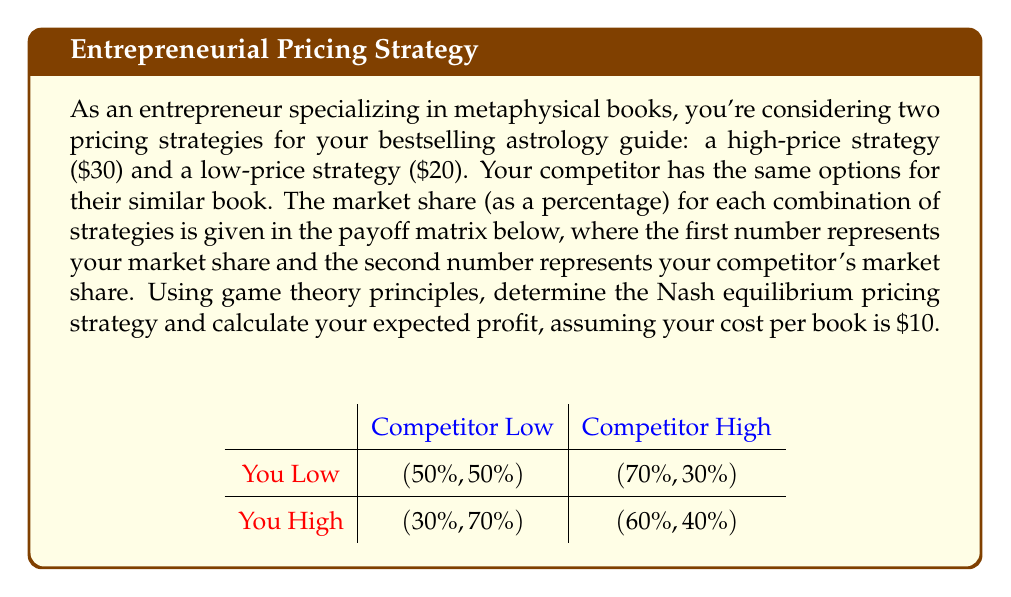Can you solve this math problem? To solve this problem, we'll follow these steps:

1. Identify the Nash equilibrium:
   A Nash equilibrium occurs when neither player can unilaterally change their strategy to increase their payoff.

   Let's analyze each scenario:
   a) If competitor chooses Low:
      - If you choose Low, your payoff is 50%
      - If you choose High, your payoff is 30%
      You prefer Low when competitor is Low.

   b) If competitor chooses High:
      - If you choose Low, your payoff is 70%
      - If you choose High, your payoff is 60%
      You prefer Low when competitor is High.

   c) If you choose Low:
      - If competitor chooses Low, their payoff is 50%
      - If competitor chooses High, their payoff is 30%
      Competitor prefers Low when you are Low.

   d) If you choose High:
      - If competitor chooses Low, their payoff is 70%
      - If competitor chooses High, their payoff is 40%
      Competitor prefers Low when you are High.

   The Nash equilibrium is (Low, Low), as neither player has an incentive to change their strategy unilaterally.

2. Calculate expected profit:
   At the Nash equilibrium (Low, Low):
   - Your market share is 50%
   - Your price is $20
   - Your cost per book is $10

   Profit per book = Price - Cost = $20 - $10 = $10

   To calculate total profit, we need to know the market size. Let's assume a market size of 1000 books.

   Your expected sales = 50% of 1000 = 500 books
   
   Expected profit = Profit per book × Expected sales
   $$\text{Expected profit} = \$10 \times 500 = \$5000$$
Answer: The Nash equilibrium pricing strategy is (Low, Low), where both you and your competitor choose the low-price strategy of $20. Your expected profit, assuming a market size of 1000 books, is $5000. 